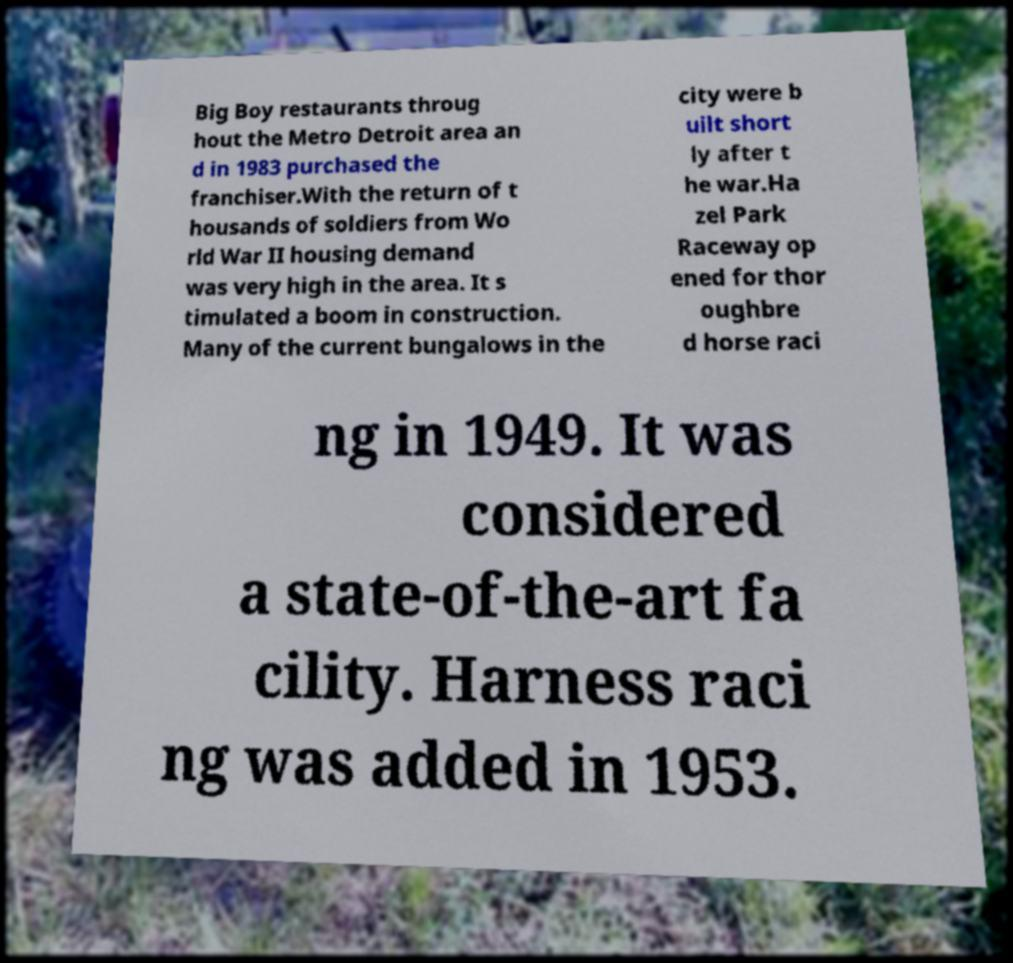What messages or text are displayed in this image? I need them in a readable, typed format. Big Boy restaurants throug hout the Metro Detroit area an d in 1983 purchased the franchiser.With the return of t housands of soldiers from Wo rld War II housing demand was very high in the area. It s timulated a boom in construction. Many of the current bungalows in the city were b uilt short ly after t he war.Ha zel Park Raceway op ened for thor oughbre d horse raci ng in 1949. It was considered a state-of-the-art fa cility. Harness raci ng was added in 1953. 